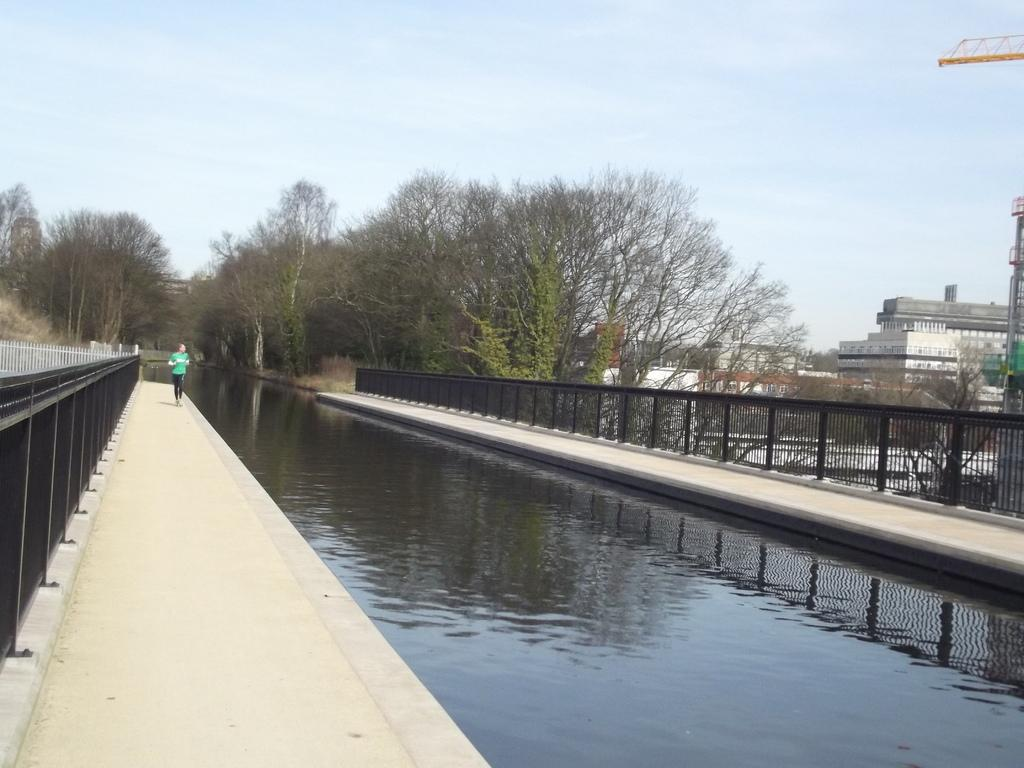What is the main feature in the center of the image? There is water in the center of the image. What is located beside the water? There are roads beside the water. What type of barrier is present beside the road? There is a metal fence beside the road. What can be seen in the background of the image? There are buildings, trees, and a crane visible in the background. What part of the natural environment is visible in the image? The sky is visible in the background of the image. What is the average income of the people living near the water in the image? There is no information about the income of people living near the water in the image. What type of quilt is draped over the crane in the background? There is no quilt present in the image, and the crane is not draped with any fabric. 